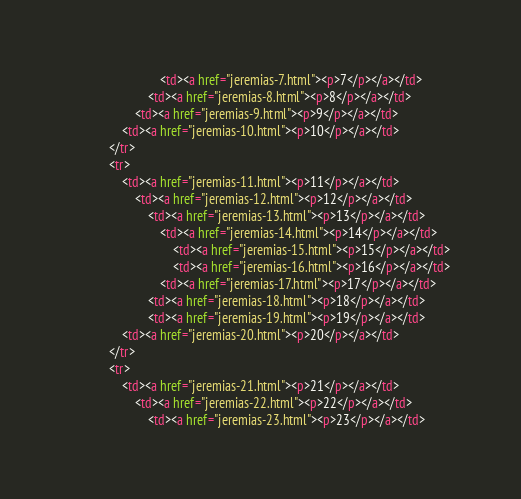Convert code to text. <code><loc_0><loc_0><loc_500><loc_500><_HTML_>                            <td><a href="jeremias-7.html"><p>7</p></a></td>
                        <td><a href="jeremias-8.html"><p>8</p></a></td>
                    <td><a href="jeremias-9.html"><p>9</p></a></td>
                <td><a href="jeremias-10.html"><p>10</p></a></td>
            </tr>
            <tr>
                <td><a href="jeremias-11.html"><p>11</p></a></td>
                    <td><a href="jeremias-12.html"><p>12</p></a></td>
                        <td><a href="jeremias-13.html"><p>13</p></a></td>
                            <td><a href="jeremias-14.html"><p>14</p></a></td>
                                <td><a href="jeremias-15.html"><p>15</p></a></td>
                                <td><a href="jeremias-16.html"><p>16</p></a></td>
                            <td><a href="jeremias-17.html"><p>17</p></a></td>
                        <td><a href="jeremias-18.html"><p>18</p></a></td>
                        <td><a href="jeremias-19.html"><p>19</p></a></td>
                <td><a href="jeremias-20.html"><p>20</p></a></td>
            </tr>
            <tr>
                <td><a href="jeremias-21.html"><p>21</p></a></td>
                    <td><a href="jeremias-22.html"><p>22</p></a></td>
                        <td><a href="jeremias-23.html"><p>23</p></a></td></code> 